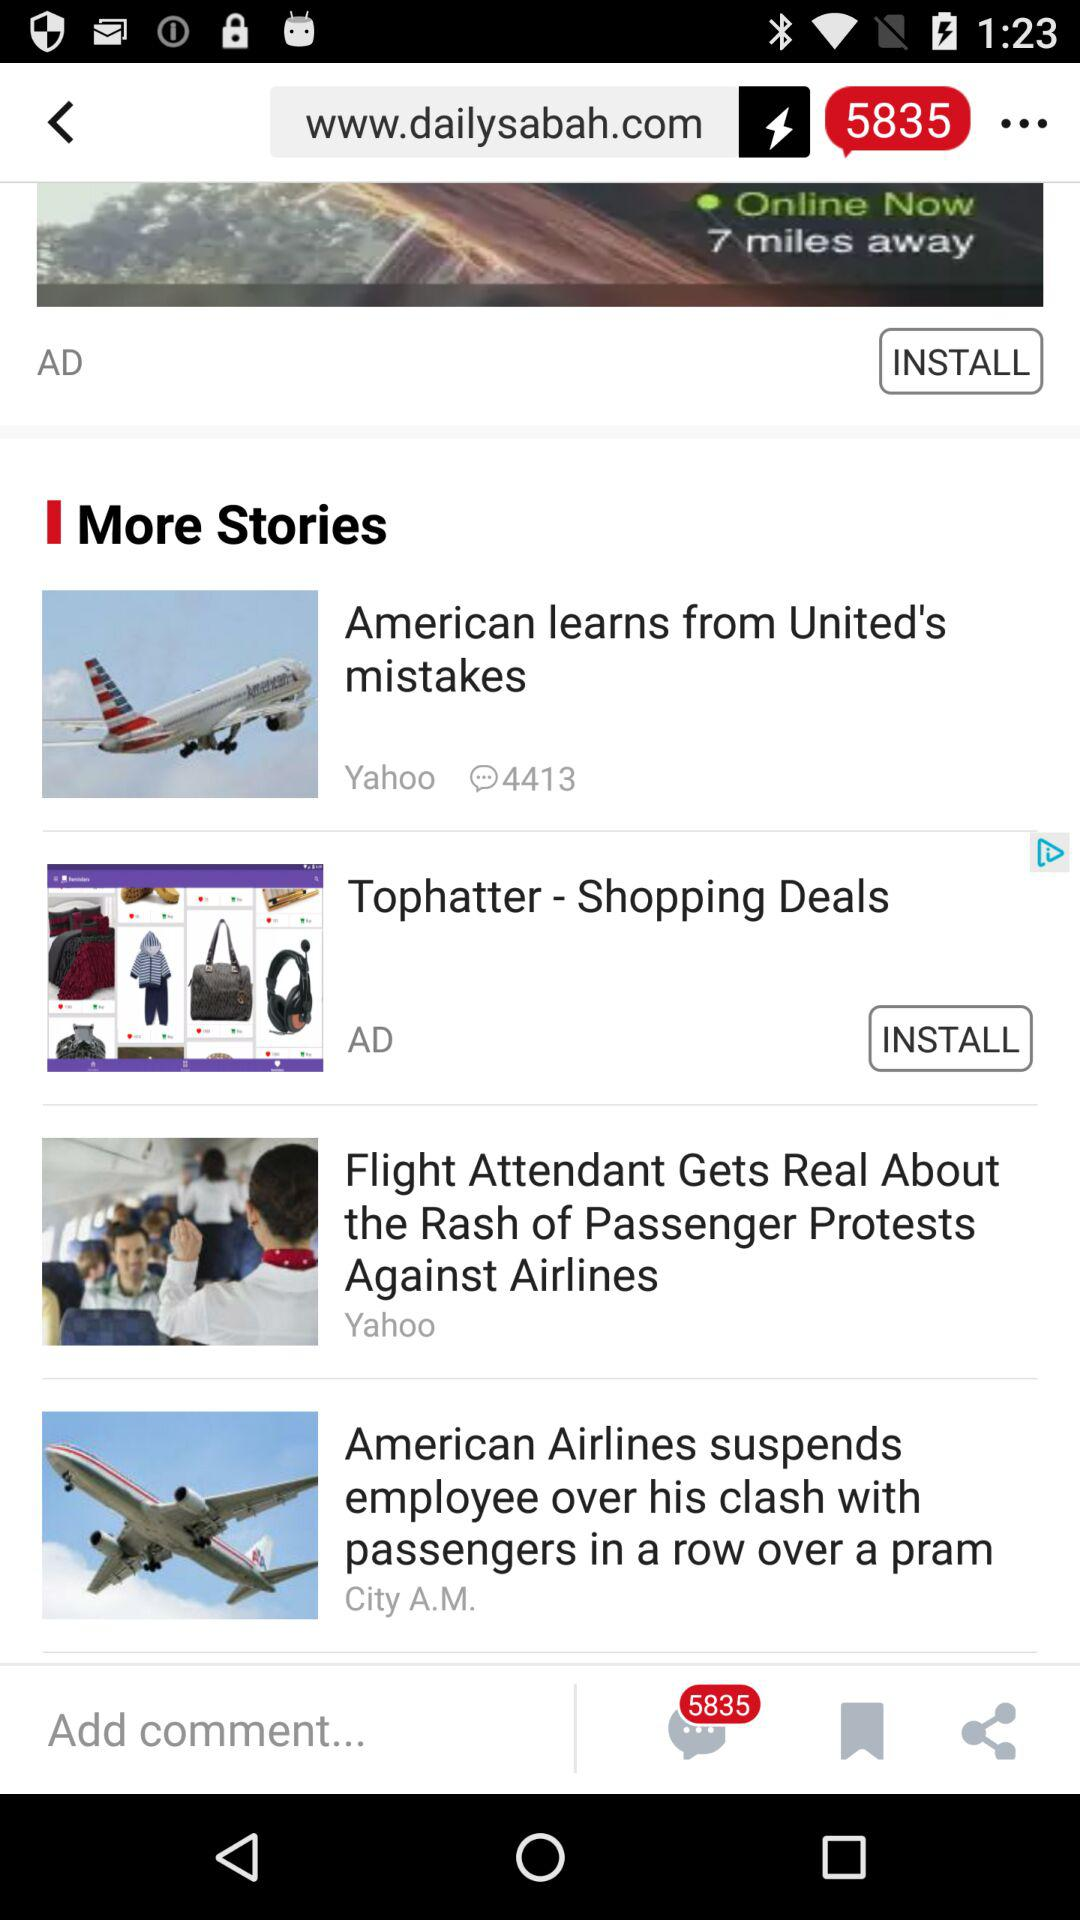How many stories are not sponsored?
Answer the question using a single word or phrase. 3 